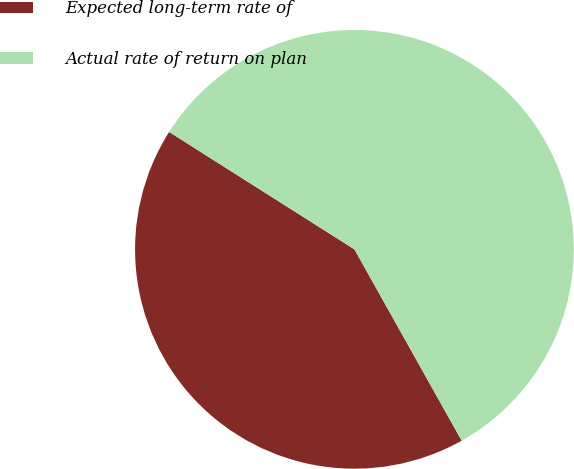Convert chart. <chart><loc_0><loc_0><loc_500><loc_500><pie_chart><fcel>Expected long-term rate of<fcel>Actual rate of return on plan<nl><fcel>42.12%<fcel>57.88%<nl></chart> 